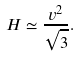<formula> <loc_0><loc_0><loc_500><loc_500>H \simeq \frac { v ^ { 2 } } { \sqrt { 3 } } .</formula> 